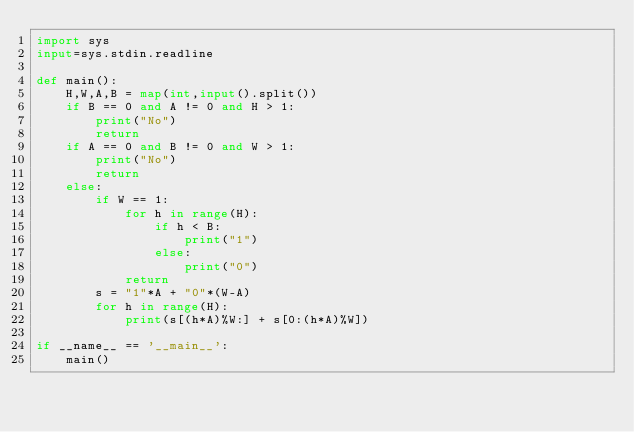<code> <loc_0><loc_0><loc_500><loc_500><_Python_>import sys
input=sys.stdin.readline

def main():
    H,W,A,B = map(int,input().split())
    if B == 0 and A != 0 and H > 1:
        print("No")
        return
    if A == 0 and B != 0 and W > 1:
        print("No")
        return
    else:
        if W == 1:
            for h in range(H):
                if h < B:
                    print("1")
                else:
                    print("0")
            return
        s = "1"*A + "0"*(W-A)
        for h in range(H):
            print(s[(h*A)%W:] + s[0:(h*A)%W])

if __name__ == '__main__':
    main()
</code> 